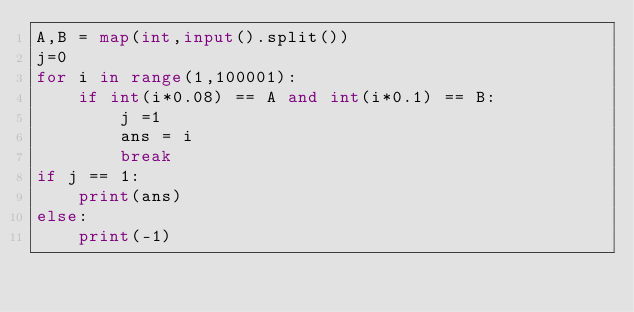Convert code to text. <code><loc_0><loc_0><loc_500><loc_500><_Python_>A,B = map(int,input().split())
j=0
for i in range(1,100001):
    if int(i*0.08) == A and int(i*0.1) == B:
        j =1
        ans = i
        break
if j == 1:
    print(ans)
else:
    print(-1)</code> 